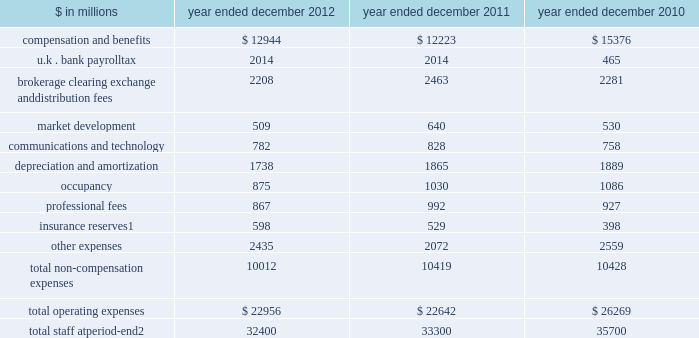Management 2019s discussion and analysis net interest income 2012 versus 2011 .
Net interest income on the consolidated statements of earnings was $ 3.88 billion for 2012 , 25% ( 25 % ) lower than 2011 .
The decrease compared with 2011 was primarily due to lower average yields on financial instruments owned , at fair value , and collateralized agreements .
2011 versus 2010 .
Net interest income on the consolidated statements of earnings was $ 5.19 billion for 2011 , 6% ( 6 % ) lower than 2010 .
The decrease compared with 2010 was primarily due to higher interest expense related to our long-term borrowings and higher dividend expense related to financial instruments sold , but not yet purchased , partially offset by an increase in interest income from higher yielding collateralized agreements .
Operating expenses our operating expenses are primarily influenced by compensation , headcount and levels of business activity .
Compensation and benefits includes salaries , discretionary compensation , amortization of equity awards and other items such as benefits .
Discretionary compensation is significantly impacted by , among other factors , the level of net revenues , overall financial performance , prevailing labor markets , business mix , the structure of our share-based compensation programs and the external environment .
In the context of more difficult economic and financial conditions , the firm launched an initiative during the second quarter of 2011 to identify areas where we can operate more efficiently and reduce our operating expenses .
During 2012 and 2011 , we announced targeted annual run rate compensation and non-compensation reductions of approximately $ 1.9 billion in aggregate .
The table below presents our operating expenses and total staff. .
Total staff at period-end 2 32400 33300 35700 1 .
Related revenues are included in 201cmarket making 201d on the consolidated statements of earnings .
Includes employees , consultants and temporary staff .
48 goldman sachs 2012 annual report .
What is the percentage change in total operating expenses in 2012? 
Computations: ((22956 - 22642) / 22642)
Answer: 0.01387. 